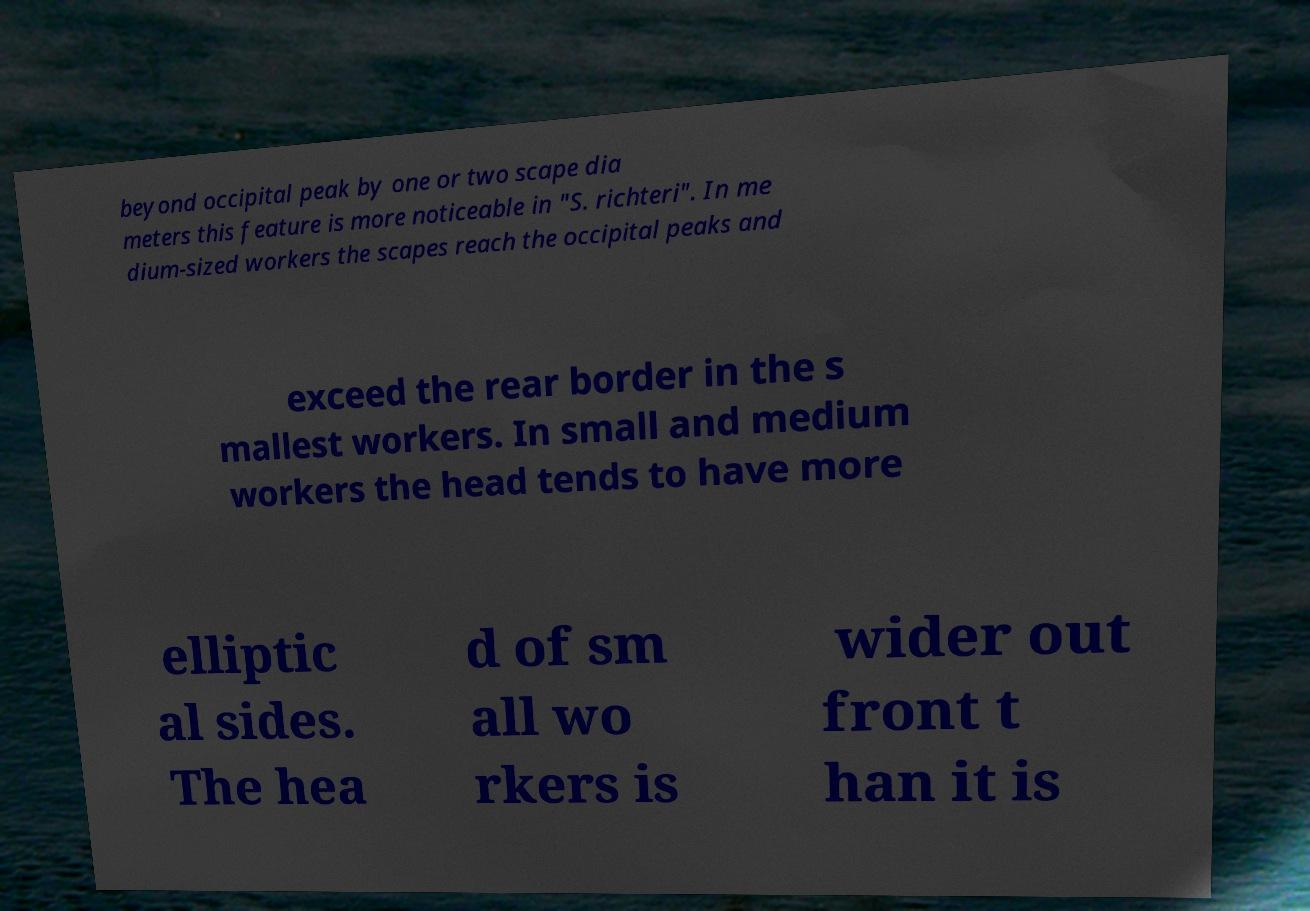What messages or text are displayed in this image? I need them in a readable, typed format. beyond occipital peak by one or two scape dia meters this feature is more noticeable in "S. richteri". In me dium-sized workers the scapes reach the occipital peaks and exceed the rear border in the s mallest workers. In small and medium workers the head tends to have more elliptic al sides. The hea d of sm all wo rkers is wider out front t han it is 